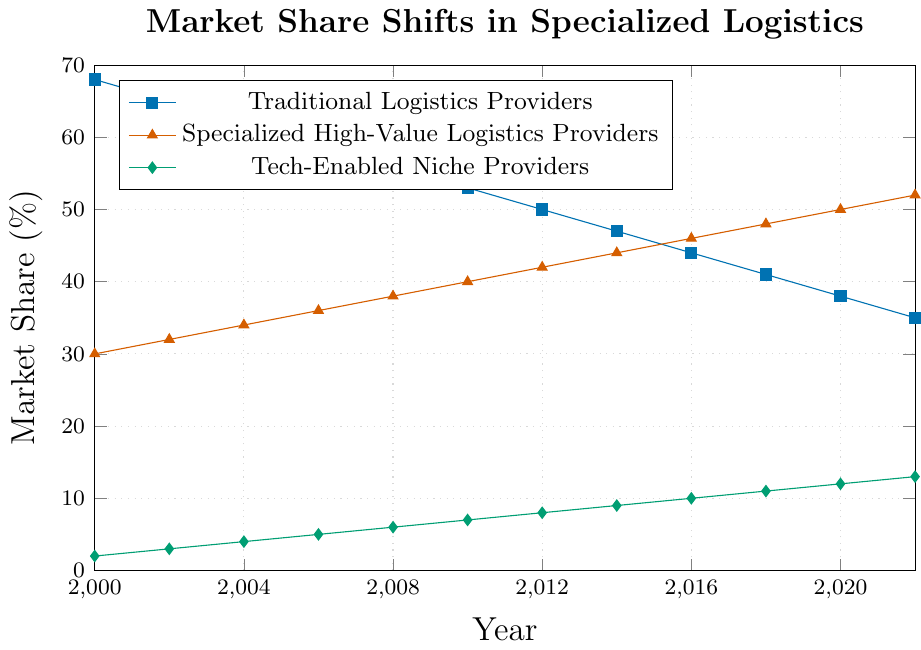What was the market share of Specialized High-Value Logistics Providers in 2010? First, look for the year 2010 on the x-axis, then trace up vertically until you intersect the line representing Specialized High-Value Logistics Providers. Read the market share value on the y-axis where the intersection occurs.
Answer: 40% How much did the market share for Traditional Logistics Providers decrease between 2000 and 2022? Determine the market share for Traditional Logistics Providers in 2000 and 2022 by looking at the y-axis values. Subtract the market share value in 2022 from the value in 2000: 68% - 35% = 33%.
Answer: 33% Which provider category showed the most significant growth from 2000 to 2022? Compare the increase in market share for each category from 2000 to 2022. Traditional Logistics Providers decreased, so they can be excluded. Calculate the difference for Specialized High-Value Logistics Providers (52% - 30% = 22%) and Tech-Enabled Niche Providers (13% - 2% = 11%). Specialized High-Value Logistics Providers had the largest increase.
Answer: Specialized High-Value Logistics Providers In which years was the market share of Specialized High-Value Logistics Providers equal to the sum of Tech-Enabled Niche Providers and half of Traditional Logistics Providers? Check each year’s values: For example, in 2004, Specialized High-Value Logistics Providers had 34%, Tech-Enabled Niche Providers had 4%, and half of Traditional Logistics Providers was 31% (62/2); adding these gives 4 + 31 = 35, not equal to 34%. Repeat for other years. In 2022, 52% (Specialized) is not equal to 13% (Tech-Enabled) + 35/2 (17.5%), so none of the years fit this condition directly.
Answer: None Did Tech-Enabled Niche Providers ever surpass Traditional Logistics Providers in market share over the years? Compare the value of Tech-Enabled Niche Providers and Traditional Logistics Providers each year by looking at their respective lines on the graph. Traditional Logistics Providers always had a higher market share than Tech-Enabled Niche Providers throughout the given period.
Answer: No What is the total market share percentage covered by all providers in 2022? Add the market share values of Traditional Logistics Providers, Specialized High-Value Logistics Providers, and Tech-Enabled Niche Providers for 2022: 35% + 52% + 13%. This totals 100%.
Answer: 100% In which period did Specialized High-Value Logistics Providers show the largest increase in market share? By examining the slopes of the lines representing Specialized High-Value Logistics Providers, identify the period with the steepest slope. The slope appears consistent but is steeper from 2000 to 2010 and less so afterward. Explicitly, the increase is largest from 2000 to 2010 (from 30% to 40%, an increase of 10 percentage points).
Answer: 2000 to 2010 In 2018, how did the combined market share of Tech-Enabled Niche Providers and Specialized High-Value Logistics Providers compare with that of Traditional Logistics Providers? Add the market share values of Tech-Enabled Niche Providers and Specialized High-Value Logistics Providers in 2018: 11% + 48% = 59%. Compare this with the market share of Traditional Logistics Providers, which is 41%. 59% is greater than 41%.
Answer: Greater What was the average market share of Specialized High-Value Logistics Providers over the period from 2000 to 2022? Sum the market share values of Specialized High-Value Logistics Providers for each year, then divide by the number of years. (30 + 32 + 34 + 36 + 38 + 40 + 42 + 44 + 46 + 48 + 50 + 52) / 12 = 42.
Answer: 42% 